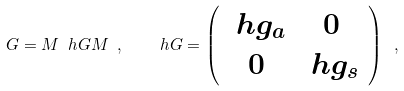<formula> <loc_0><loc_0><loc_500><loc_500>G = M \ h G M \ , \quad \ h G = \left ( \begin{array} { c c } \ h g _ { a } & 0 \\ 0 & \ h g _ { s } \\ \end{array} \right ) \ ,</formula> 